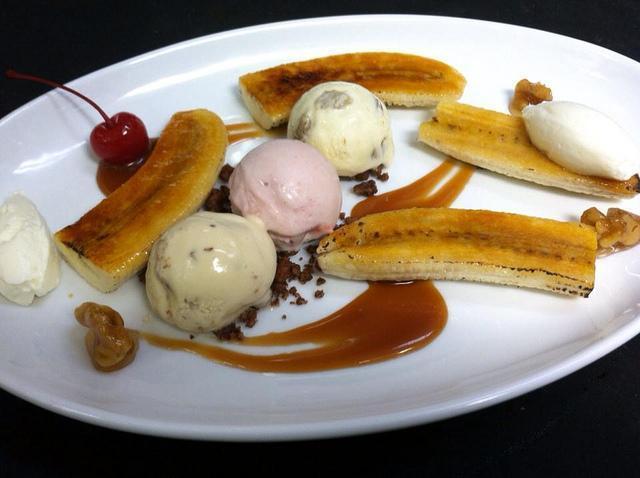How many pieces of banana are on this plate?
Give a very brief answer. 4. How many bananas are visible?
Give a very brief answer. 5. 